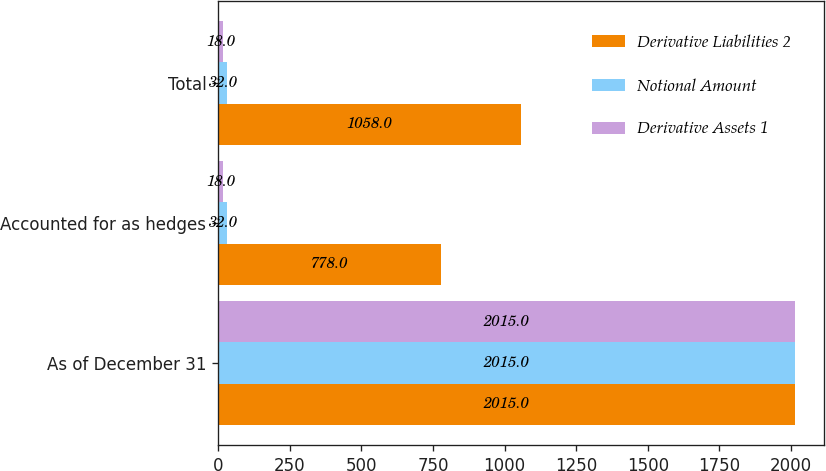<chart> <loc_0><loc_0><loc_500><loc_500><stacked_bar_chart><ecel><fcel>As of December 31<fcel>Accounted for as hedges<fcel>Total<nl><fcel>Derivative Liabilities 2<fcel>2015<fcel>778<fcel>1058<nl><fcel>Notional Amount<fcel>2015<fcel>32<fcel>32<nl><fcel>Derivative Assets 1<fcel>2015<fcel>18<fcel>18<nl></chart> 